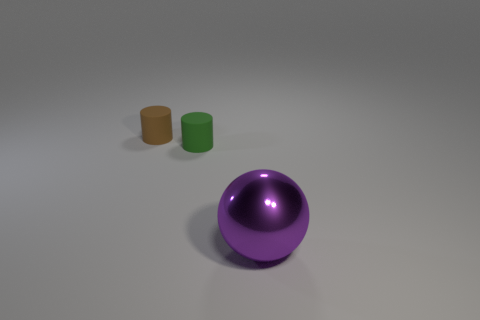Add 2 green rubber cylinders. How many objects exist? 5 Subtract all cylinders. How many objects are left? 1 Add 1 tiny matte cylinders. How many tiny matte cylinders are left? 3 Add 1 tiny green things. How many tiny green things exist? 2 Subtract 0 gray cubes. How many objects are left? 3 Subtract all tiny cylinders. Subtract all green cylinders. How many objects are left? 0 